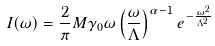<formula> <loc_0><loc_0><loc_500><loc_500>I ( \omega ) = \frac { 2 } { \pi } M \gamma _ { 0 } \omega \left ( \frac { \omega } { \Lambda } \right ) ^ { \alpha - 1 } e ^ { - \frac { \omega ^ { 2 } } { \Lambda ^ { 2 } } }</formula> 